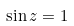<formula> <loc_0><loc_0><loc_500><loc_500>\sin z = 1</formula> 